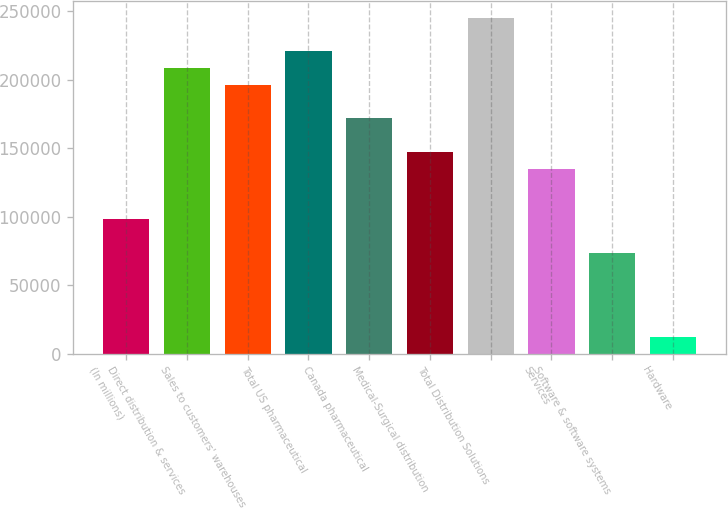Convert chart. <chart><loc_0><loc_0><loc_500><loc_500><bar_chart><fcel>(In millions)<fcel>Direct distribution & services<fcel>Sales to customers' warehouses<fcel>Total US pharmaceutical<fcel>Canada pharmaceutical<fcel>Medical-Surgical distribution<fcel>Total Distribution Solutions<fcel>Services<fcel>Software & software systems<fcel>Hardware<nl><fcel>98210.6<fcel>208566<fcel>196304<fcel>220828<fcel>171781<fcel>147257<fcel>245351<fcel>134996<fcel>73687.2<fcel>12378.7<nl></chart> 